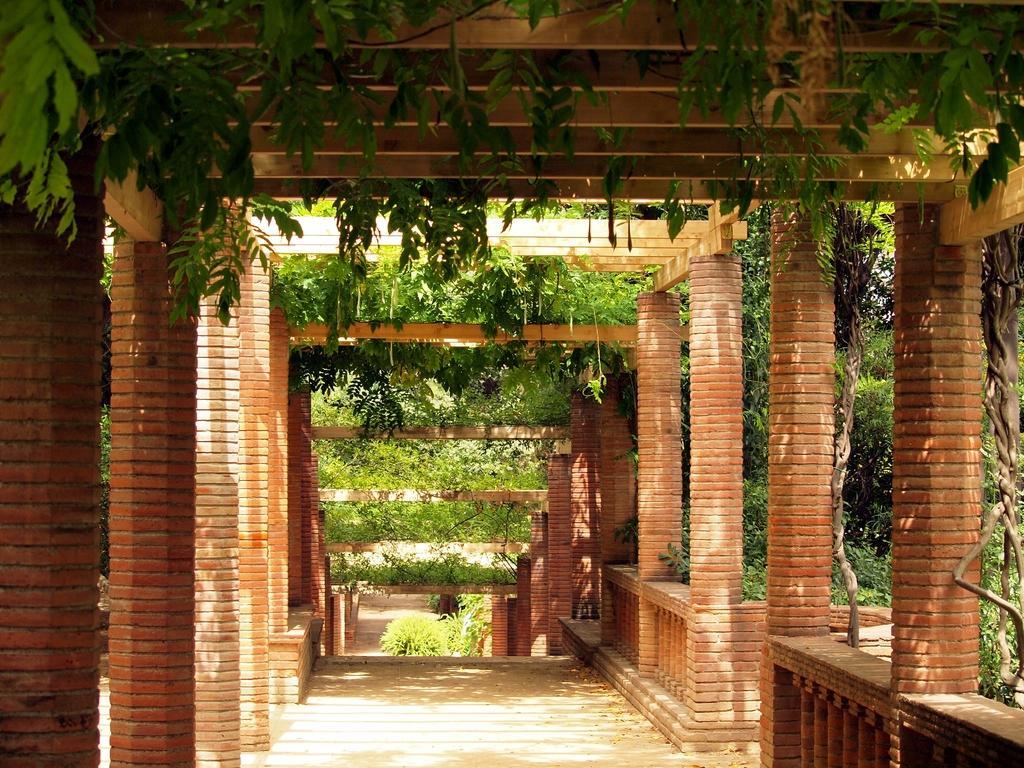Could you give a brief overview of what you see in this image? It looks like an outdoor garden, it has many pillars and also stairs downwards and there are some plants around that area. 